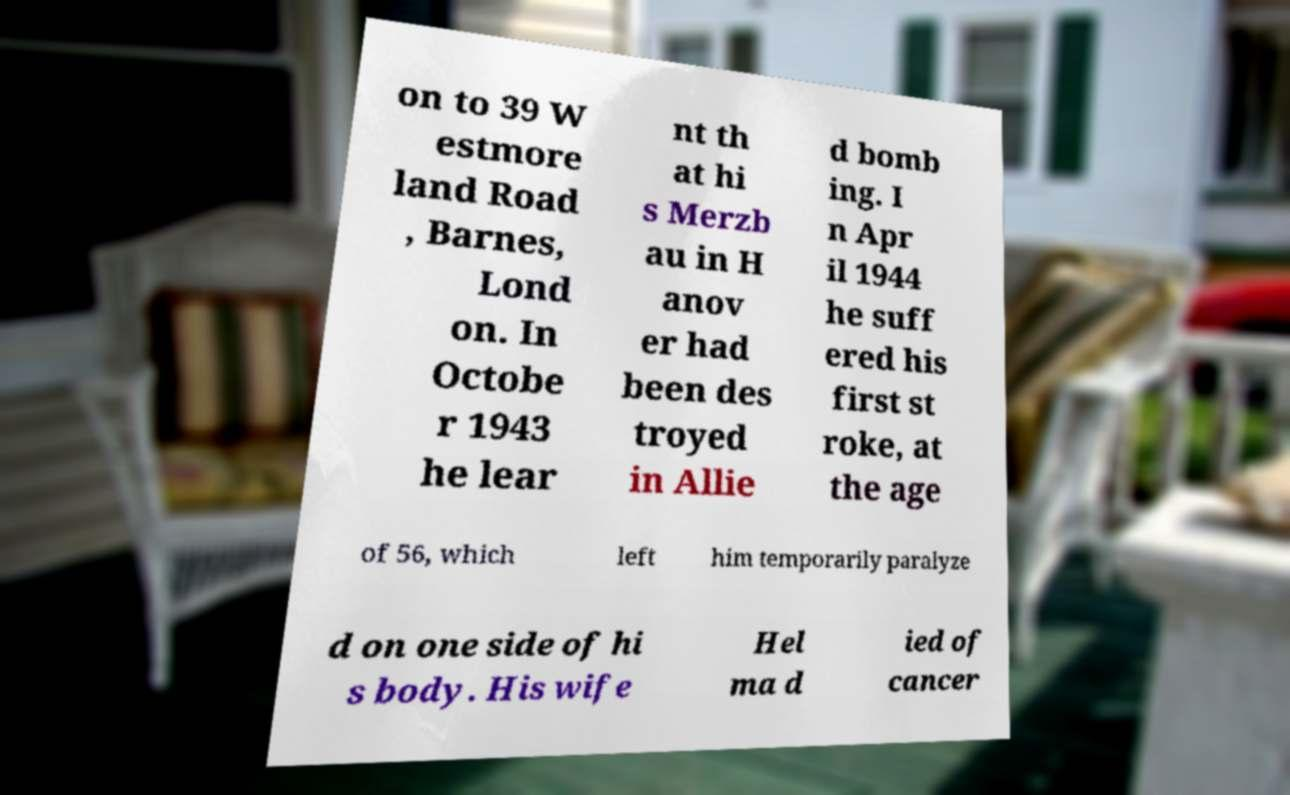For documentation purposes, I need the text within this image transcribed. Could you provide that? on to 39 W estmore land Road , Barnes, Lond on. In Octobe r 1943 he lear nt th at hi s Merzb au in H anov er had been des troyed in Allie d bomb ing. I n Apr il 1944 he suff ered his first st roke, at the age of 56, which left him temporarily paralyze d on one side of hi s body. His wife Hel ma d ied of cancer 